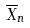<formula> <loc_0><loc_0><loc_500><loc_500>\overline { X } _ { n }</formula> 